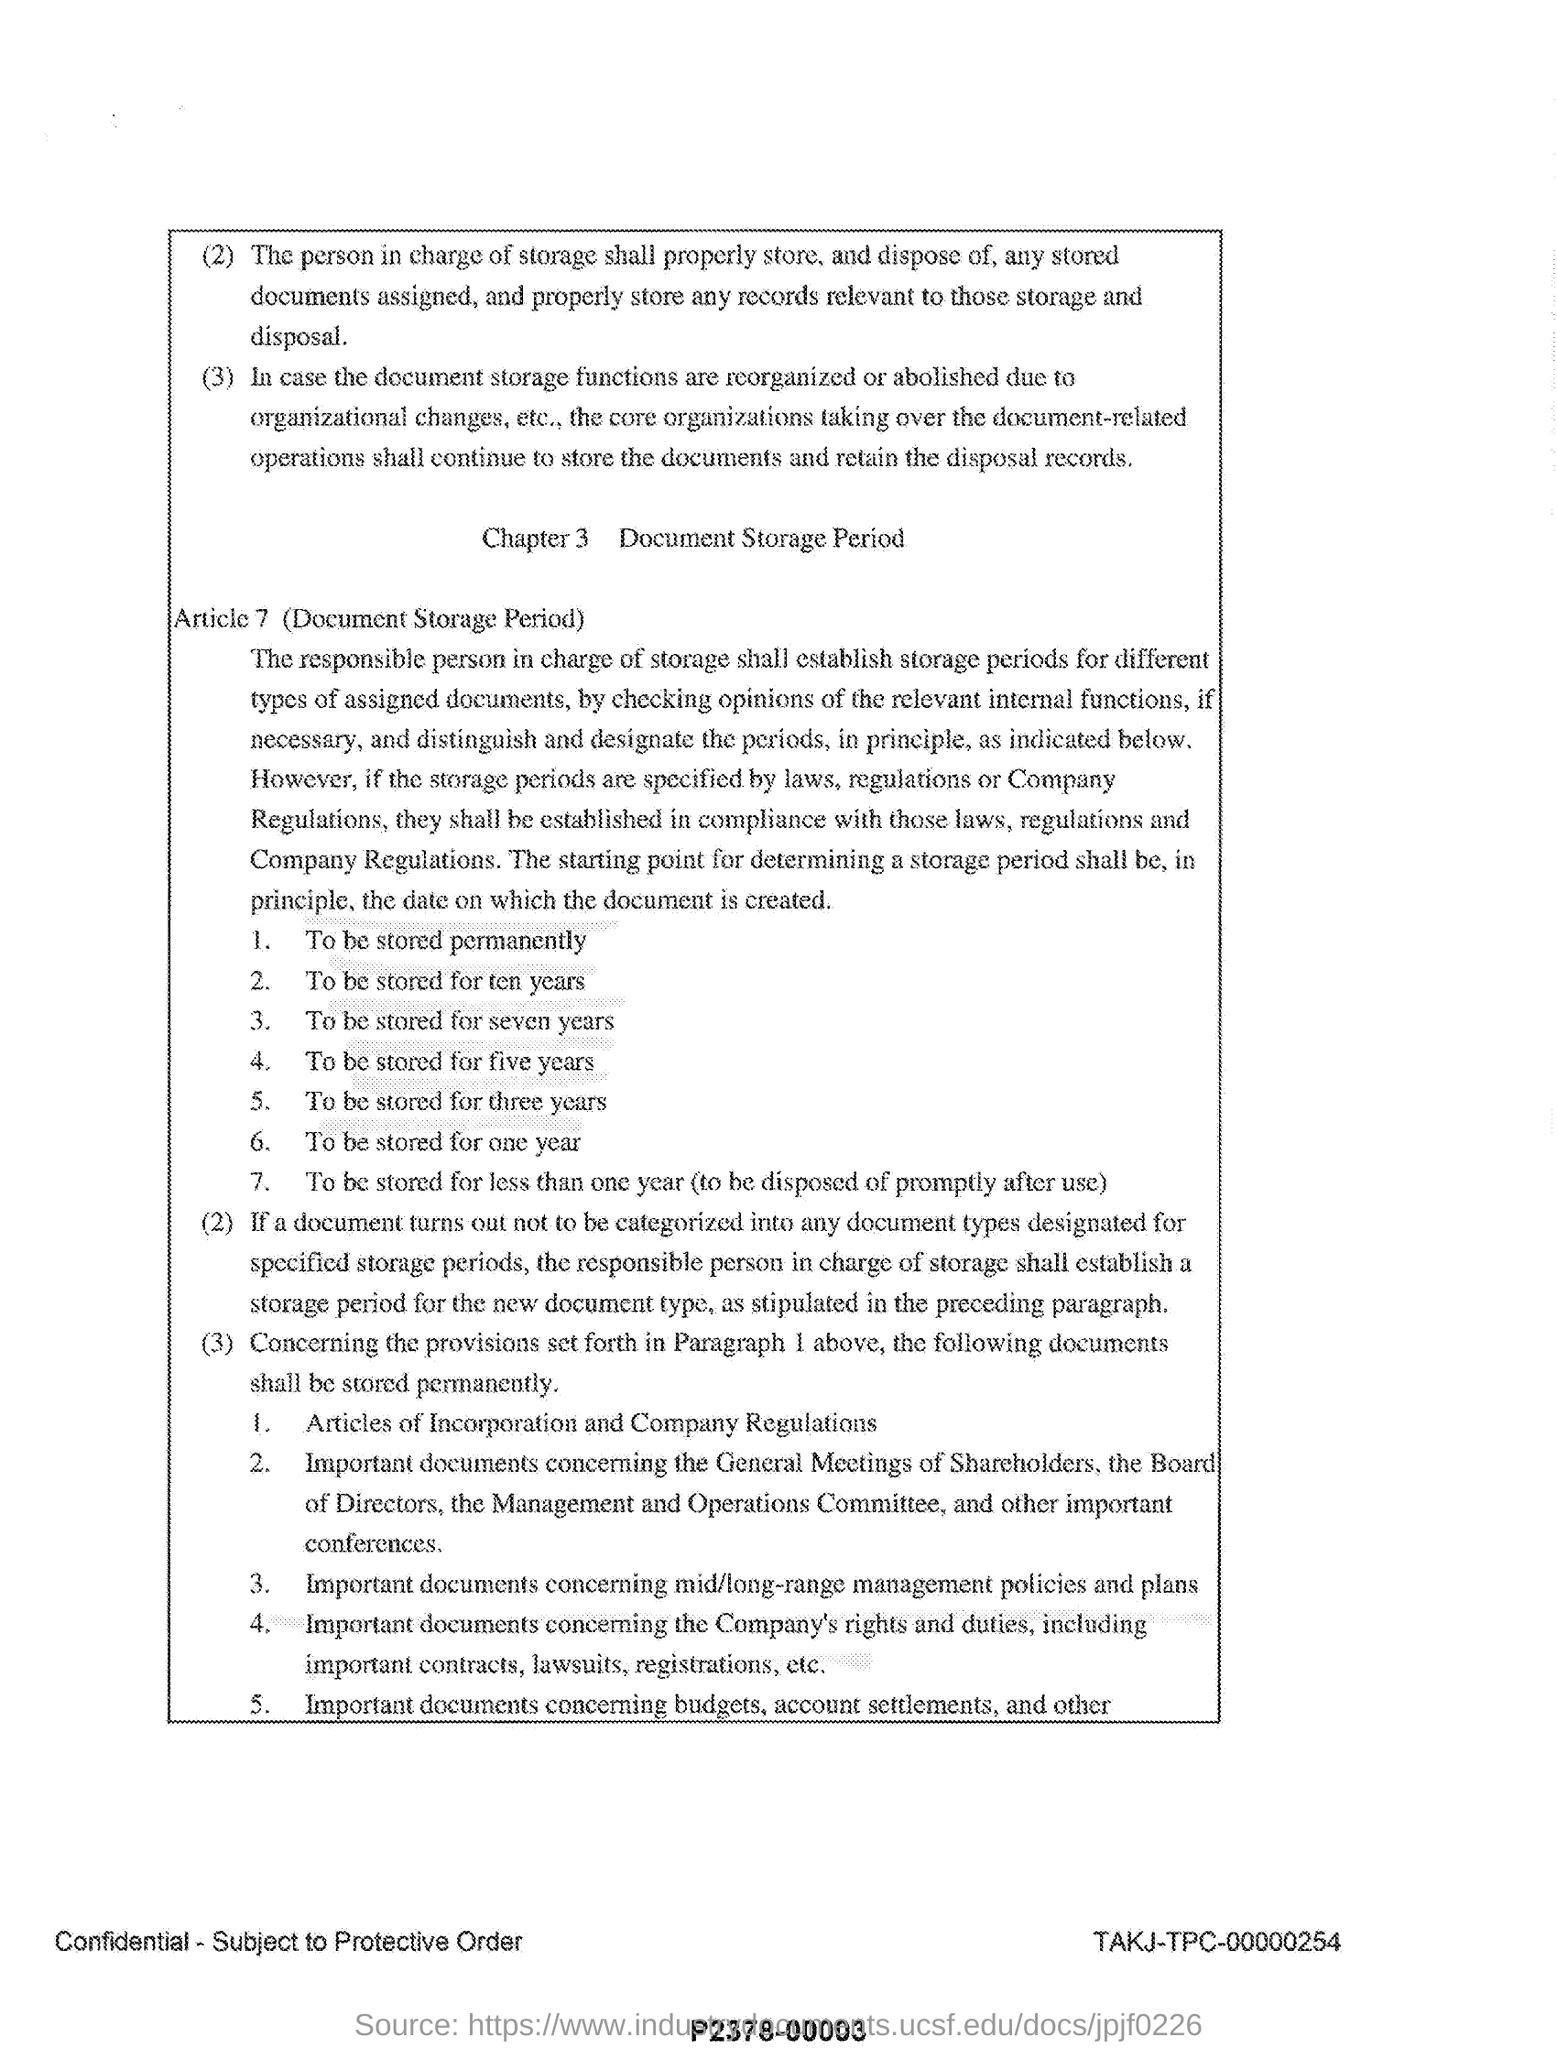Outline some significant characteristics in this image. The title of Chapter 3 is "Document Storage Period". Under Article 7, the second point listed specifies that document storage periods shall be ten years. The document storage period is 7 years, as stated in Article 7. 